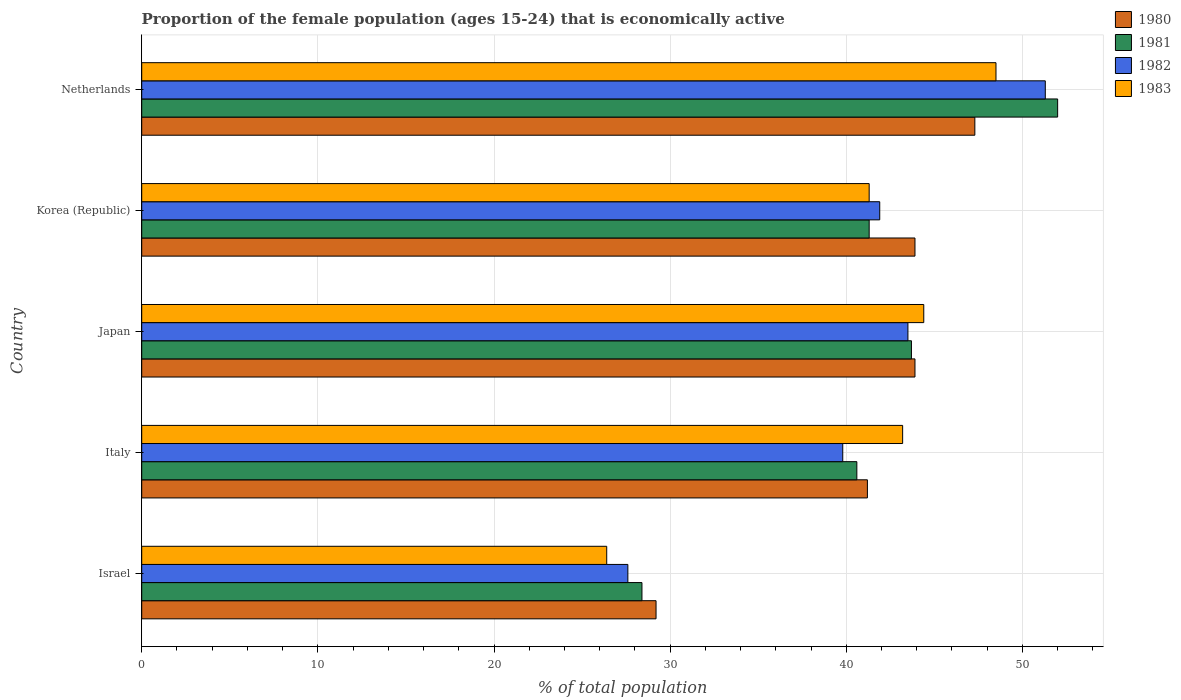How many different coloured bars are there?
Provide a short and direct response. 4. How many groups of bars are there?
Make the answer very short. 5. Are the number of bars on each tick of the Y-axis equal?
Offer a terse response. Yes. How many bars are there on the 2nd tick from the top?
Provide a short and direct response. 4. How many bars are there on the 5th tick from the bottom?
Your answer should be compact. 4. What is the label of the 3rd group of bars from the top?
Ensure brevity in your answer.  Japan. In how many cases, is the number of bars for a given country not equal to the number of legend labels?
Give a very brief answer. 0. What is the proportion of the female population that is economically active in 1980 in Israel?
Ensure brevity in your answer.  29.2. Across all countries, what is the maximum proportion of the female population that is economically active in 1981?
Ensure brevity in your answer.  52. Across all countries, what is the minimum proportion of the female population that is economically active in 1982?
Ensure brevity in your answer.  27.6. In which country was the proportion of the female population that is economically active in 1981 minimum?
Give a very brief answer. Israel. What is the total proportion of the female population that is economically active in 1982 in the graph?
Your answer should be compact. 204.1. What is the difference between the proportion of the female population that is economically active in 1981 in Italy and that in Japan?
Provide a short and direct response. -3.1. What is the difference between the proportion of the female population that is economically active in 1982 in Japan and the proportion of the female population that is economically active in 1981 in Korea (Republic)?
Provide a short and direct response. 2.2. What is the average proportion of the female population that is economically active in 1983 per country?
Give a very brief answer. 40.76. What is the difference between the proportion of the female population that is economically active in 1983 and proportion of the female population that is economically active in 1980 in Israel?
Your answer should be very brief. -2.8. In how many countries, is the proportion of the female population that is economically active in 1983 greater than 48 %?
Offer a very short reply. 1. What is the ratio of the proportion of the female population that is economically active in 1981 in Italy to that in Netherlands?
Make the answer very short. 0.78. Is the proportion of the female population that is economically active in 1981 in Israel less than that in Japan?
Your answer should be compact. Yes. Is the difference between the proportion of the female population that is economically active in 1983 in Israel and Netherlands greater than the difference between the proportion of the female population that is economically active in 1980 in Israel and Netherlands?
Provide a succinct answer. No. What is the difference between the highest and the second highest proportion of the female population that is economically active in 1981?
Your answer should be compact. 8.3. What is the difference between the highest and the lowest proportion of the female population that is economically active in 1981?
Offer a terse response. 23.6. What does the 2nd bar from the top in Israel represents?
Make the answer very short. 1982. How many bars are there?
Your response must be concise. 20. Does the graph contain grids?
Provide a short and direct response. Yes. How many legend labels are there?
Your answer should be very brief. 4. How are the legend labels stacked?
Offer a very short reply. Vertical. What is the title of the graph?
Make the answer very short. Proportion of the female population (ages 15-24) that is economically active. What is the label or title of the X-axis?
Offer a terse response. % of total population. What is the label or title of the Y-axis?
Make the answer very short. Country. What is the % of total population of 1980 in Israel?
Your response must be concise. 29.2. What is the % of total population of 1981 in Israel?
Offer a terse response. 28.4. What is the % of total population of 1982 in Israel?
Keep it short and to the point. 27.6. What is the % of total population in 1983 in Israel?
Provide a succinct answer. 26.4. What is the % of total population of 1980 in Italy?
Give a very brief answer. 41.2. What is the % of total population of 1981 in Italy?
Offer a terse response. 40.6. What is the % of total population of 1982 in Italy?
Provide a succinct answer. 39.8. What is the % of total population in 1983 in Italy?
Offer a terse response. 43.2. What is the % of total population in 1980 in Japan?
Offer a terse response. 43.9. What is the % of total population in 1981 in Japan?
Your answer should be very brief. 43.7. What is the % of total population of 1982 in Japan?
Keep it short and to the point. 43.5. What is the % of total population of 1983 in Japan?
Offer a very short reply. 44.4. What is the % of total population in 1980 in Korea (Republic)?
Your answer should be compact. 43.9. What is the % of total population of 1981 in Korea (Republic)?
Your answer should be compact. 41.3. What is the % of total population in 1982 in Korea (Republic)?
Offer a terse response. 41.9. What is the % of total population of 1983 in Korea (Republic)?
Your answer should be compact. 41.3. What is the % of total population in 1980 in Netherlands?
Give a very brief answer. 47.3. What is the % of total population in 1982 in Netherlands?
Your response must be concise. 51.3. What is the % of total population in 1983 in Netherlands?
Ensure brevity in your answer.  48.5. Across all countries, what is the maximum % of total population in 1980?
Keep it short and to the point. 47.3. Across all countries, what is the maximum % of total population in 1981?
Make the answer very short. 52. Across all countries, what is the maximum % of total population of 1982?
Offer a very short reply. 51.3. Across all countries, what is the maximum % of total population of 1983?
Offer a very short reply. 48.5. Across all countries, what is the minimum % of total population of 1980?
Your answer should be compact. 29.2. Across all countries, what is the minimum % of total population of 1981?
Offer a very short reply. 28.4. Across all countries, what is the minimum % of total population of 1982?
Make the answer very short. 27.6. Across all countries, what is the minimum % of total population of 1983?
Provide a succinct answer. 26.4. What is the total % of total population of 1980 in the graph?
Provide a succinct answer. 205.5. What is the total % of total population in 1981 in the graph?
Offer a very short reply. 206. What is the total % of total population in 1982 in the graph?
Your answer should be very brief. 204.1. What is the total % of total population of 1983 in the graph?
Your answer should be very brief. 203.8. What is the difference between the % of total population in 1981 in Israel and that in Italy?
Keep it short and to the point. -12.2. What is the difference between the % of total population in 1983 in Israel and that in Italy?
Provide a succinct answer. -16.8. What is the difference between the % of total population of 1980 in Israel and that in Japan?
Offer a very short reply. -14.7. What is the difference between the % of total population in 1981 in Israel and that in Japan?
Make the answer very short. -15.3. What is the difference between the % of total population of 1982 in Israel and that in Japan?
Give a very brief answer. -15.9. What is the difference between the % of total population in 1980 in Israel and that in Korea (Republic)?
Provide a succinct answer. -14.7. What is the difference between the % of total population of 1981 in Israel and that in Korea (Republic)?
Make the answer very short. -12.9. What is the difference between the % of total population in 1982 in Israel and that in Korea (Republic)?
Offer a terse response. -14.3. What is the difference between the % of total population in 1983 in Israel and that in Korea (Republic)?
Your response must be concise. -14.9. What is the difference between the % of total population in 1980 in Israel and that in Netherlands?
Provide a succinct answer. -18.1. What is the difference between the % of total population in 1981 in Israel and that in Netherlands?
Your answer should be very brief. -23.6. What is the difference between the % of total population in 1982 in Israel and that in Netherlands?
Keep it short and to the point. -23.7. What is the difference between the % of total population in 1983 in Israel and that in Netherlands?
Your answer should be very brief. -22.1. What is the difference between the % of total population in 1981 in Italy and that in Japan?
Your answer should be very brief. -3.1. What is the difference between the % of total population in 1980 in Italy and that in Korea (Republic)?
Offer a very short reply. -2.7. What is the difference between the % of total population of 1982 in Italy and that in Korea (Republic)?
Offer a very short reply. -2.1. What is the difference between the % of total population in 1983 in Italy and that in Korea (Republic)?
Keep it short and to the point. 1.9. What is the difference between the % of total population of 1982 in Italy and that in Netherlands?
Provide a short and direct response. -11.5. What is the difference between the % of total population of 1983 in Italy and that in Netherlands?
Offer a terse response. -5.3. What is the difference between the % of total population in 1981 in Japan and that in Korea (Republic)?
Give a very brief answer. 2.4. What is the difference between the % of total population of 1982 in Japan and that in Korea (Republic)?
Ensure brevity in your answer.  1.6. What is the difference between the % of total population of 1980 in Japan and that in Netherlands?
Your answer should be very brief. -3.4. What is the difference between the % of total population in 1981 in Japan and that in Netherlands?
Ensure brevity in your answer.  -8.3. What is the difference between the % of total population in 1983 in Japan and that in Netherlands?
Make the answer very short. -4.1. What is the difference between the % of total population of 1980 in Korea (Republic) and that in Netherlands?
Make the answer very short. -3.4. What is the difference between the % of total population in 1981 in Korea (Republic) and that in Netherlands?
Your answer should be very brief. -10.7. What is the difference between the % of total population in 1983 in Korea (Republic) and that in Netherlands?
Offer a very short reply. -7.2. What is the difference between the % of total population of 1980 in Israel and the % of total population of 1982 in Italy?
Your answer should be compact. -10.6. What is the difference between the % of total population in 1981 in Israel and the % of total population in 1982 in Italy?
Keep it short and to the point. -11.4. What is the difference between the % of total population in 1981 in Israel and the % of total population in 1983 in Italy?
Your response must be concise. -14.8. What is the difference between the % of total population in 1982 in Israel and the % of total population in 1983 in Italy?
Your response must be concise. -15.6. What is the difference between the % of total population of 1980 in Israel and the % of total population of 1982 in Japan?
Your answer should be compact. -14.3. What is the difference between the % of total population of 1980 in Israel and the % of total population of 1983 in Japan?
Ensure brevity in your answer.  -15.2. What is the difference between the % of total population in 1981 in Israel and the % of total population in 1982 in Japan?
Your answer should be very brief. -15.1. What is the difference between the % of total population of 1982 in Israel and the % of total population of 1983 in Japan?
Offer a terse response. -16.8. What is the difference between the % of total population in 1980 in Israel and the % of total population in 1983 in Korea (Republic)?
Offer a terse response. -12.1. What is the difference between the % of total population of 1981 in Israel and the % of total population of 1983 in Korea (Republic)?
Provide a short and direct response. -12.9. What is the difference between the % of total population of 1982 in Israel and the % of total population of 1983 in Korea (Republic)?
Offer a terse response. -13.7. What is the difference between the % of total population of 1980 in Israel and the % of total population of 1981 in Netherlands?
Offer a terse response. -22.8. What is the difference between the % of total population of 1980 in Israel and the % of total population of 1982 in Netherlands?
Offer a terse response. -22.1. What is the difference between the % of total population in 1980 in Israel and the % of total population in 1983 in Netherlands?
Your answer should be compact. -19.3. What is the difference between the % of total population of 1981 in Israel and the % of total population of 1982 in Netherlands?
Offer a very short reply. -22.9. What is the difference between the % of total population of 1981 in Israel and the % of total population of 1983 in Netherlands?
Your answer should be very brief. -20.1. What is the difference between the % of total population in 1982 in Israel and the % of total population in 1983 in Netherlands?
Give a very brief answer. -20.9. What is the difference between the % of total population in 1980 in Italy and the % of total population in 1981 in Japan?
Your answer should be compact. -2.5. What is the difference between the % of total population of 1981 in Italy and the % of total population of 1982 in Japan?
Offer a very short reply. -2.9. What is the difference between the % of total population in 1981 in Italy and the % of total population in 1983 in Japan?
Make the answer very short. -3.8. What is the difference between the % of total population in 1982 in Italy and the % of total population in 1983 in Japan?
Give a very brief answer. -4.6. What is the difference between the % of total population of 1980 in Italy and the % of total population of 1981 in Korea (Republic)?
Give a very brief answer. -0.1. What is the difference between the % of total population of 1980 in Italy and the % of total population of 1983 in Korea (Republic)?
Offer a terse response. -0.1. What is the difference between the % of total population in 1981 in Italy and the % of total population in 1983 in Korea (Republic)?
Make the answer very short. -0.7. What is the difference between the % of total population in 1982 in Italy and the % of total population in 1983 in Korea (Republic)?
Give a very brief answer. -1.5. What is the difference between the % of total population of 1980 in Italy and the % of total population of 1982 in Netherlands?
Provide a short and direct response. -10.1. What is the difference between the % of total population of 1980 in Italy and the % of total population of 1983 in Netherlands?
Provide a short and direct response. -7.3. What is the difference between the % of total population of 1981 in Italy and the % of total population of 1982 in Netherlands?
Give a very brief answer. -10.7. What is the difference between the % of total population of 1980 in Japan and the % of total population of 1981 in Korea (Republic)?
Your response must be concise. 2.6. What is the difference between the % of total population in 1980 in Japan and the % of total population in 1982 in Korea (Republic)?
Give a very brief answer. 2. What is the difference between the % of total population in 1981 in Japan and the % of total population in 1983 in Korea (Republic)?
Offer a terse response. 2.4. What is the difference between the % of total population in 1980 in Japan and the % of total population in 1982 in Netherlands?
Provide a succinct answer. -7.4. What is the difference between the % of total population of 1980 in Japan and the % of total population of 1983 in Netherlands?
Offer a very short reply. -4.6. What is the difference between the % of total population in 1981 in Japan and the % of total population in 1983 in Netherlands?
Your response must be concise. -4.8. What is the difference between the % of total population of 1980 in Korea (Republic) and the % of total population of 1982 in Netherlands?
Your answer should be compact. -7.4. What is the difference between the % of total population of 1981 in Korea (Republic) and the % of total population of 1982 in Netherlands?
Make the answer very short. -10. What is the difference between the % of total population in 1981 in Korea (Republic) and the % of total population in 1983 in Netherlands?
Give a very brief answer. -7.2. What is the average % of total population in 1980 per country?
Provide a short and direct response. 41.1. What is the average % of total population in 1981 per country?
Your response must be concise. 41.2. What is the average % of total population of 1982 per country?
Your answer should be very brief. 40.82. What is the average % of total population of 1983 per country?
Ensure brevity in your answer.  40.76. What is the difference between the % of total population in 1980 and % of total population in 1981 in Israel?
Ensure brevity in your answer.  0.8. What is the difference between the % of total population of 1980 and % of total population of 1983 in Israel?
Provide a short and direct response. 2.8. What is the difference between the % of total population in 1981 and % of total population in 1982 in Israel?
Offer a very short reply. 0.8. What is the difference between the % of total population in 1980 and % of total population in 1981 in Italy?
Your response must be concise. 0.6. What is the difference between the % of total population of 1980 and % of total population of 1982 in Italy?
Provide a succinct answer. 1.4. What is the difference between the % of total population of 1980 and % of total population of 1983 in Italy?
Ensure brevity in your answer.  -2. What is the difference between the % of total population in 1981 and % of total population in 1982 in Italy?
Keep it short and to the point. 0.8. What is the difference between the % of total population of 1981 and % of total population of 1983 in Italy?
Offer a very short reply. -2.6. What is the difference between the % of total population in 1980 and % of total population in 1983 in Japan?
Your answer should be very brief. -0.5. What is the difference between the % of total population in 1981 and % of total population in 1983 in Japan?
Ensure brevity in your answer.  -0.7. What is the difference between the % of total population of 1980 and % of total population of 1981 in Korea (Republic)?
Provide a succinct answer. 2.6. What is the difference between the % of total population in 1980 and % of total population in 1982 in Korea (Republic)?
Offer a very short reply. 2. What is the difference between the % of total population of 1980 and % of total population of 1983 in Korea (Republic)?
Your response must be concise. 2.6. What is the difference between the % of total population of 1981 and % of total population of 1982 in Korea (Republic)?
Provide a short and direct response. -0.6. What is the difference between the % of total population in 1982 and % of total population in 1983 in Korea (Republic)?
Provide a short and direct response. 0.6. What is the difference between the % of total population in 1980 and % of total population in 1981 in Netherlands?
Your response must be concise. -4.7. What is the difference between the % of total population of 1980 and % of total population of 1983 in Netherlands?
Ensure brevity in your answer.  -1.2. What is the difference between the % of total population in 1981 and % of total population in 1983 in Netherlands?
Offer a very short reply. 3.5. What is the ratio of the % of total population in 1980 in Israel to that in Italy?
Give a very brief answer. 0.71. What is the ratio of the % of total population in 1981 in Israel to that in Italy?
Your answer should be compact. 0.7. What is the ratio of the % of total population in 1982 in Israel to that in Italy?
Ensure brevity in your answer.  0.69. What is the ratio of the % of total population of 1983 in Israel to that in Italy?
Offer a very short reply. 0.61. What is the ratio of the % of total population of 1980 in Israel to that in Japan?
Make the answer very short. 0.67. What is the ratio of the % of total population of 1981 in Israel to that in Japan?
Provide a short and direct response. 0.65. What is the ratio of the % of total population in 1982 in Israel to that in Japan?
Keep it short and to the point. 0.63. What is the ratio of the % of total population in 1983 in Israel to that in Japan?
Offer a terse response. 0.59. What is the ratio of the % of total population in 1980 in Israel to that in Korea (Republic)?
Your answer should be compact. 0.67. What is the ratio of the % of total population in 1981 in Israel to that in Korea (Republic)?
Ensure brevity in your answer.  0.69. What is the ratio of the % of total population in 1982 in Israel to that in Korea (Republic)?
Your response must be concise. 0.66. What is the ratio of the % of total population of 1983 in Israel to that in Korea (Republic)?
Your answer should be very brief. 0.64. What is the ratio of the % of total population in 1980 in Israel to that in Netherlands?
Keep it short and to the point. 0.62. What is the ratio of the % of total population in 1981 in Israel to that in Netherlands?
Your answer should be compact. 0.55. What is the ratio of the % of total population in 1982 in Israel to that in Netherlands?
Ensure brevity in your answer.  0.54. What is the ratio of the % of total population of 1983 in Israel to that in Netherlands?
Your answer should be very brief. 0.54. What is the ratio of the % of total population of 1980 in Italy to that in Japan?
Ensure brevity in your answer.  0.94. What is the ratio of the % of total population of 1981 in Italy to that in Japan?
Provide a succinct answer. 0.93. What is the ratio of the % of total population in 1982 in Italy to that in Japan?
Provide a short and direct response. 0.91. What is the ratio of the % of total population in 1980 in Italy to that in Korea (Republic)?
Your answer should be very brief. 0.94. What is the ratio of the % of total population in 1981 in Italy to that in Korea (Republic)?
Your answer should be very brief. 0.98. What is the ratio of the % of total population in 1982 in Italy to that in Korea (Republic)?
Keep it short and to the point. 0.95. What is the ratio of the % of total population of 1983 in Italy to that in Korea (Republic)?
Provide a succinct answer. 1.05. What is the ratio of the % of total population in 1980 in Italy to that in Netherlands?
Ensure brevity in your answer.  0.87. What is the ratio of the % of total population of 1981 in Italy to that in Netherlands?
Offer a very short reply. 0.78. What is the ratio of the % of total population in 1982 in Italy to that in Netherlands?
Provide a short and direct response. 0.78. What is the ratio of the % of total population of 1983 in Italy to that in Netherlands?
Your response must be concise. 0.89. What is the ratio of the % of total population in 1981 in Japan to that in Korea (Republic)?
Provide a succinct answer. 1.06. What is the ratio of the % of total population in 1982 in Japan to that in Korea (Republic)?
Your response must be concise. 1.04. What is the ratio of the % of total population of 1983 in Japan to that in Korea (Republic)?
Ensure brevity in your answer.  1.08. What is the ratio of the % of total population of 1980 in Japan to that in Netherlands?
Keep it short and to the point. 0.93. What is the ratio of the % of total population of 1981 in Japan to that in Netherlands?
Your answer should be very brief. 0.84. What is the ratio of the % of total population in 1982 in Japan to that in Netherlands?
Ensure brevity in your answer.  0.85. What is the ratio of the % of total population of 1983 in Japan to that in Netherlands?
Make the answer very short. 0.92. What is the ratio of the % of total population of 1980 in Korea (Republic) to that in Netherlands?
Provide a succinct answer. 0.93. What is the ratio of the % of total population of 1981 in Korea (Republic) to that in Netherlands?
Provide a short and direct response. 0.79. What is the ratio of the % of total population of 1982 in Korea (Republic) to that in Netherlands?
Keep it short and to the point. 0.82. What is the ratio of the % of total population in 1983 in Korea (Republic) to that in Netherlands?
Offer a terse response. 0.85. What is the difference between the highest and the second highest % of total population of 1983?
Your response must be concise. 4.1. What is the difference between the highest and the lowest % of total population of 1980?
Your answer should be very brief. 18.1. What is the difference between the highest and the lowest % of total population of 1981?
Give a very brief answer. 23.6. What is the difference between the highest and the lowest % of total population of 1982?
Give a very brief answer. 23.7. What is the difference between the highest and the lowest % of total population in 1983?
Your response must be concise. 22.1. 